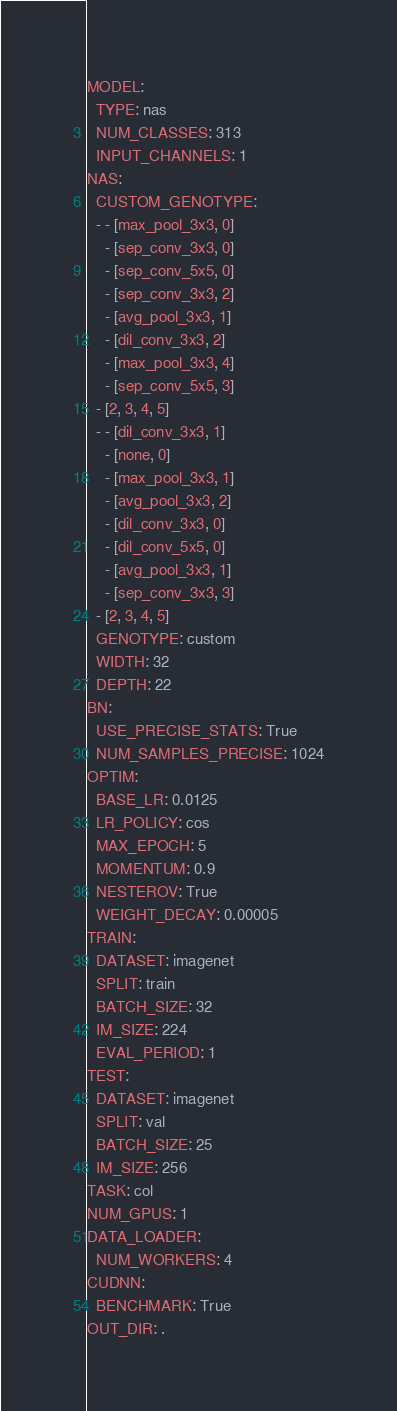<code> <loc_0><loc_0><loc_500><loc_500><_YAML_>MODEL:
  TYPE: nas
  NUM_CLASSES: 313
  INPUT_CHANNELS: 1
NAS:
  CUSTOM_GENOTYPE:
  - - [max_pool_3x3, 0]
    - [sep_conv_3x3, 0]
    - [sep_conv_5x5, 0]
    - [sep_conv_3x3, 2]
    - [avg_pool_3x3, 1]
    - [dil_conv_3x3, 2]
    - [max_pool_3x3, 4]
    - [sep_conv_5x5, 3]
  - [2, 3, 4, 5]
  - - [dil_conv_3x3, 1]
    - [none, 0]
    - [max_pool_3x3, 1]
    - [avg_pool_3x3, 2]
    - [dil_conv_3x3, 0]
    - [dil_conv_5x5, 0]
    - [avg_pool_3x3, 1]
    - [sep_conv_3x3, 3]
  - [2, 3, 4, 5]
  GENOTYPE: custom
  WIDTH: 32
  DEPTH: 22
BN:
  USE_PRECISE_STATS: True
  NUM_SAMPLES_PRECISE: 1024
OPTIM:
  BASE_LR: 0.0125
  LR_POLICY: cos
  MAX_EPOCH: 5
  MOMENTUM: 0.9
  NESTEROV: True
  WEIGHT_DECAY: 0.00005
TRAIN:
  DATASET: imagenet
  SPLIT: train
  BATCH_SIZE: 32
  IM_SIZE: 224
  EVAL_PERIOD: 1
TEST:
  DATASET: imagenet
  SPLIT: val
  BATCH_SIZE: 25
  IM_SIZE: 256
TASK: col
NUM_GPUS: 1
DATA_LOADER:
  NUM_WORKERS: 4
CUDNN:
  BENCHMARK: True
OUT_DIR: .
</code> 